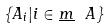<formula> <loc_0><loc_0><loc_500><loc_500>\{ A _ { i } | i \in \underline { m } \ A \}</formula> 